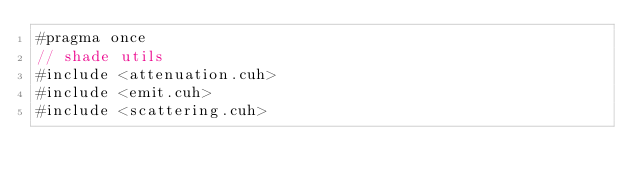Convert code to text. <code><loc_0><loc_0><loc_500><loc_500><_Cuda_>#pragma once
// shade utils
#include <attenuation.cuh>
#include <emit.cuh>
#include <scattering.cuh>
</code> 